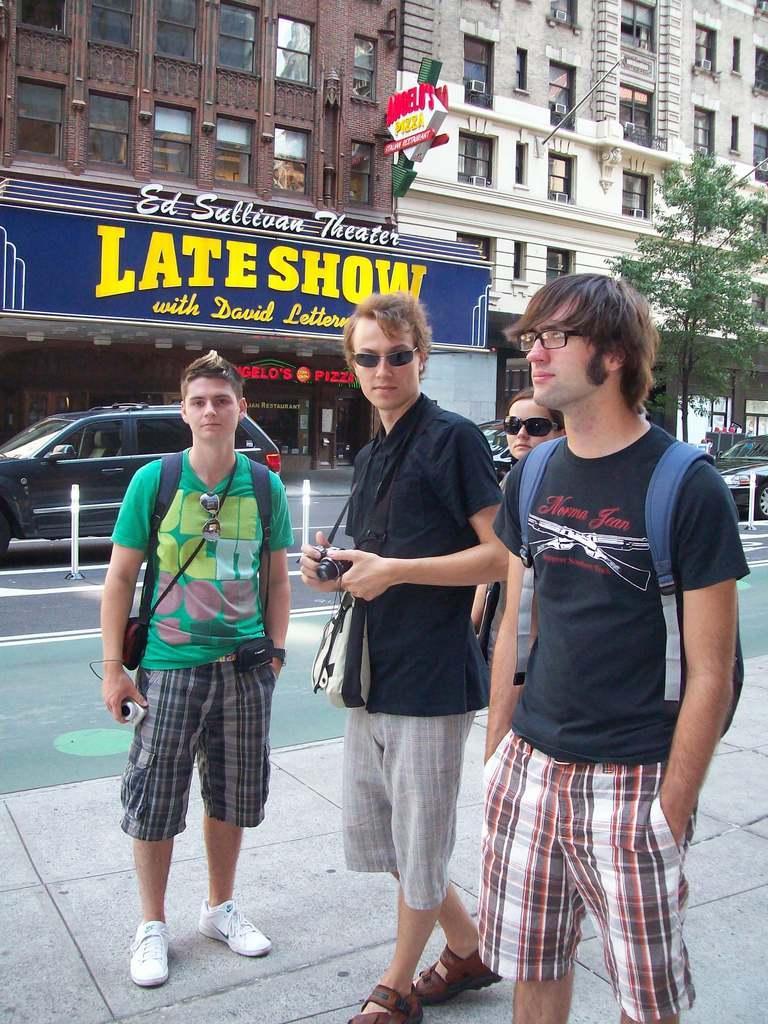In one or two sentences, can you explain what this image depicts? In this image I can see few people are standing. I can see two of them are wearing black dress and I can see they are carrying bags. In background I can see buildings, boards, a tree and few vehicles on road. I can also see something is written on these boards and here I can see two of them are carrying cameras. 